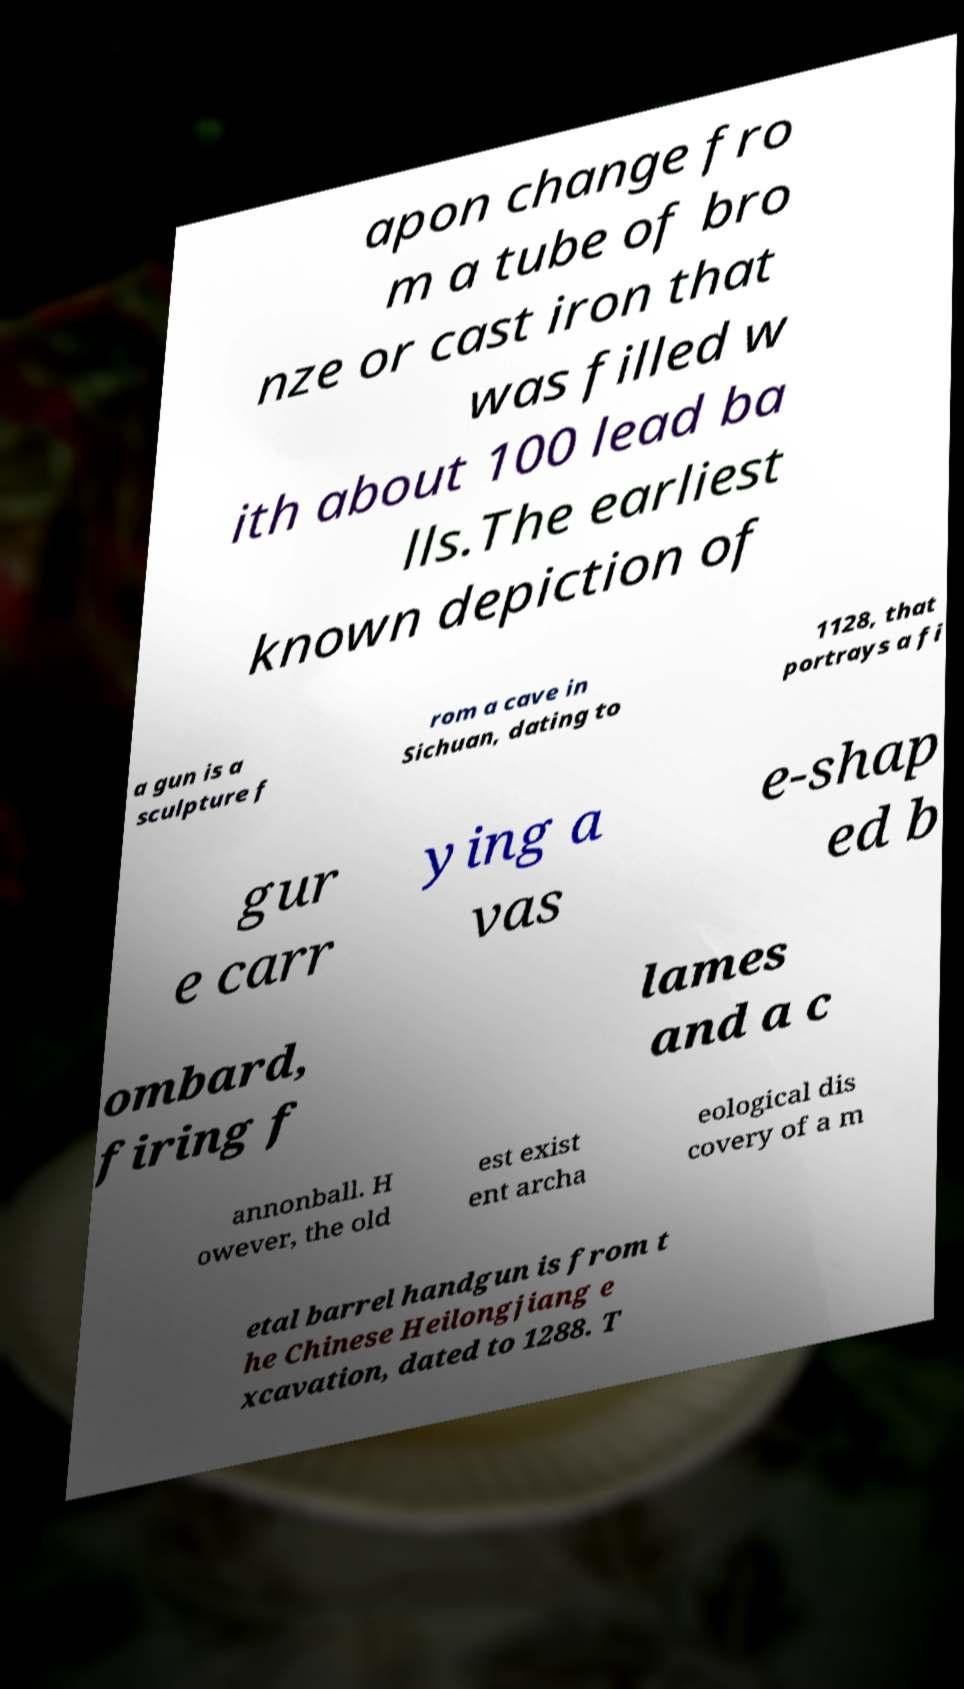Please read and relay the text visible in this image. What does it say? apon change fro m a tube of bro nze or cast iron that was filled w ith about 100 lead ba lls.The earliest known depiction of a gun is a sculpture f rom a cave in Sichuan, dating to 1128, that portrays a fi gur e carr ying a vas e-shap ed b ombard, firing f lames and a c annonball. H owever, the old est exist ent archa eological dis covery of a m etal barrel handgun is from t he Chinese Heilongjiang e xcavation, dated to 1288. T 